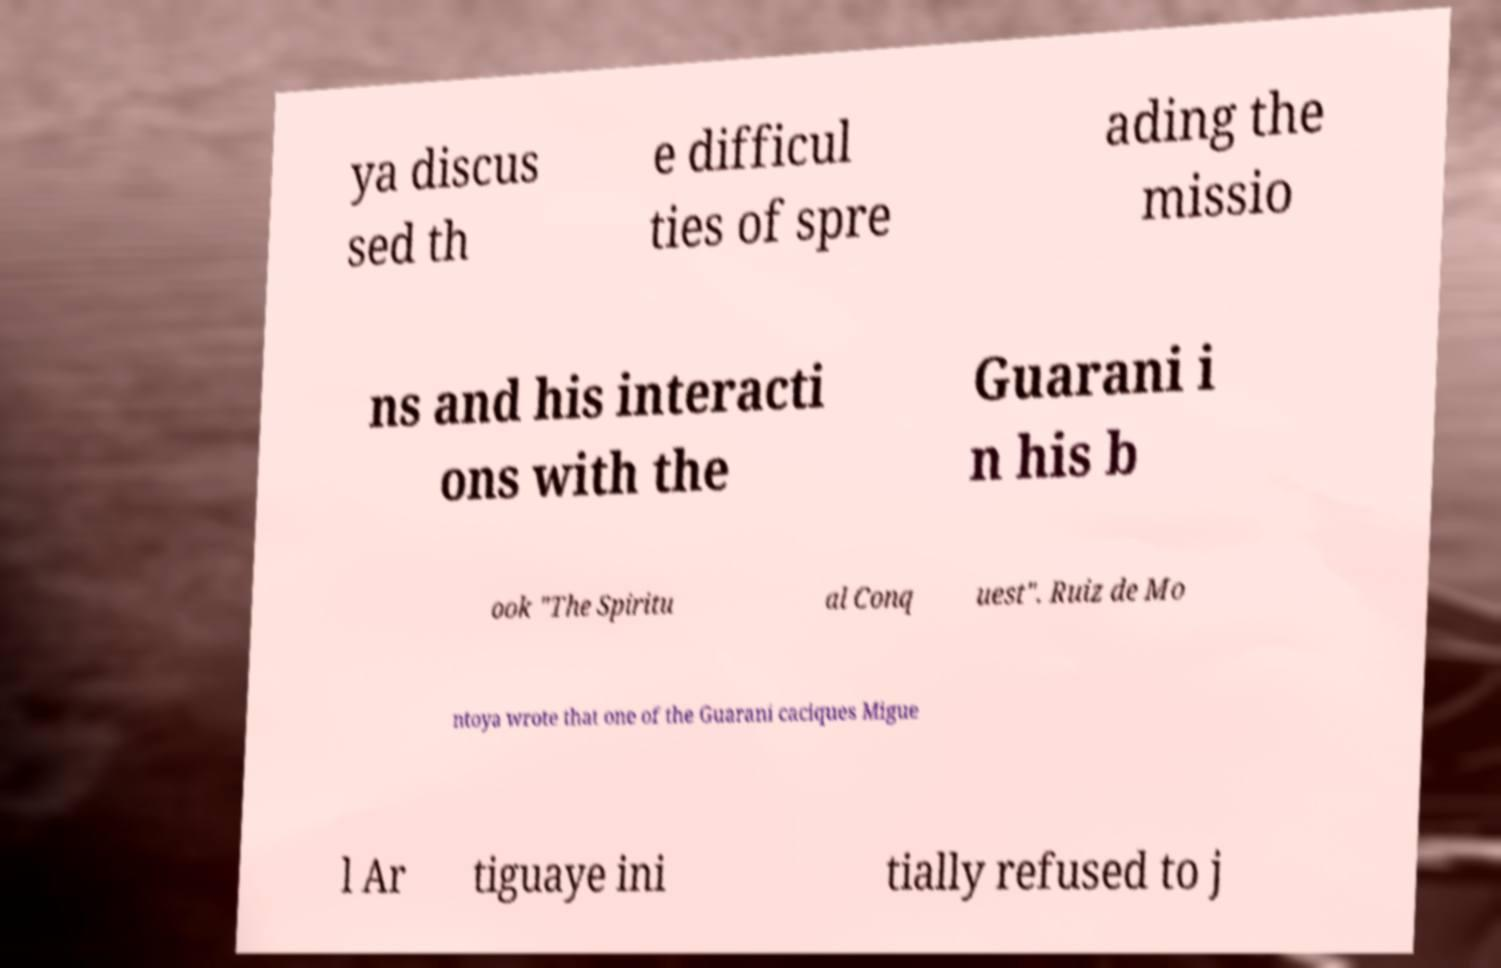Could you assist in decoding the text presented in this image and type it out clearly? ya discus sed th e difficul ties of spre ading the missio ns and his interacti ons with the Guarani i n his b ook "The Spiritu al Conq uest". Ruiz de Mo ntoya wrote that one of the Guarani caciques Migue l Ar tiguaye ini tially refused to j 